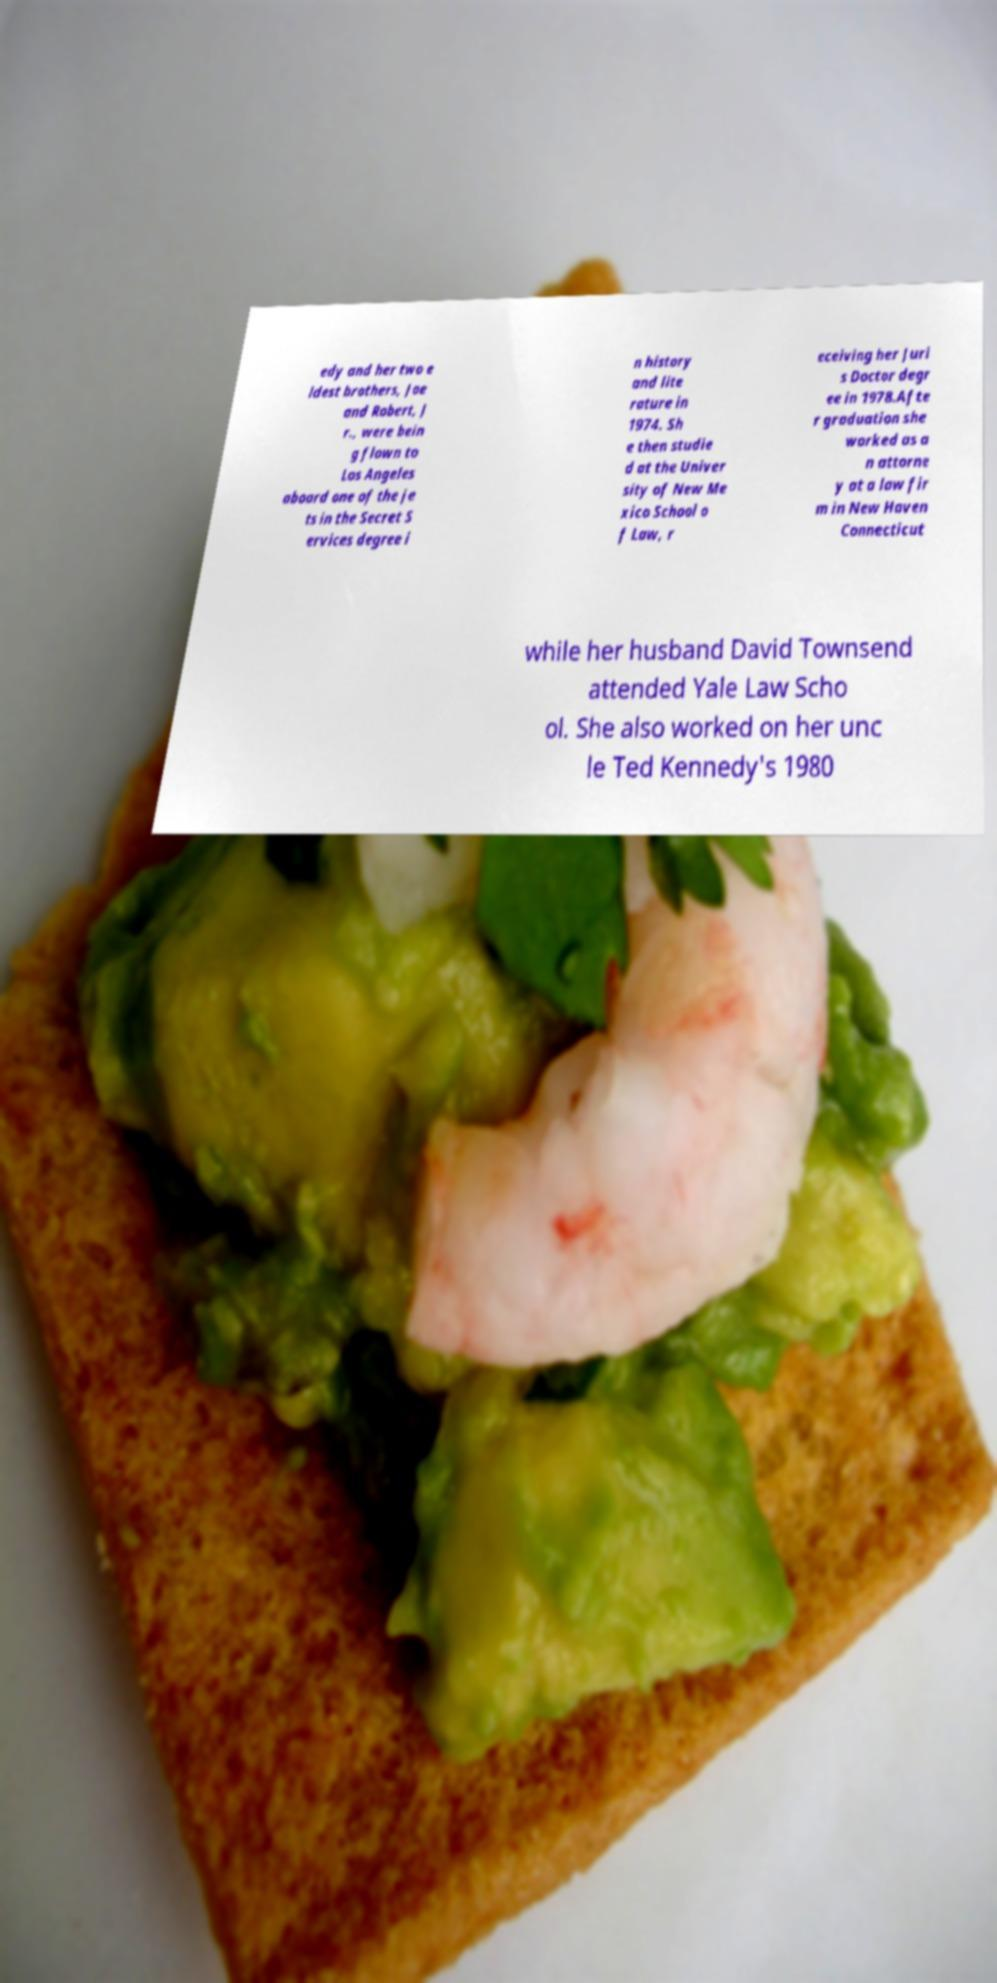There's text embedded in this image that I need extracted. Can you transcribe it verbatim? edy and her two e ldest brothers, Joe and Robert, J r., were bein g flown to Los Angeles aboard one of the je ts in the Secret S ervices degree i n history and lite rature in 1974. Sh e then studie d at the Univer sity of New Me xico School o f Law, r eceiving her Juri s Doctor degr ee in 1978.Afte r graduation she worked as a n attorne y at a law fir m in New Haven Connecticut while her husband David Townsend attended Yale Law Scho ol. She also worked on her unc le Ted Kennedy's 1980 